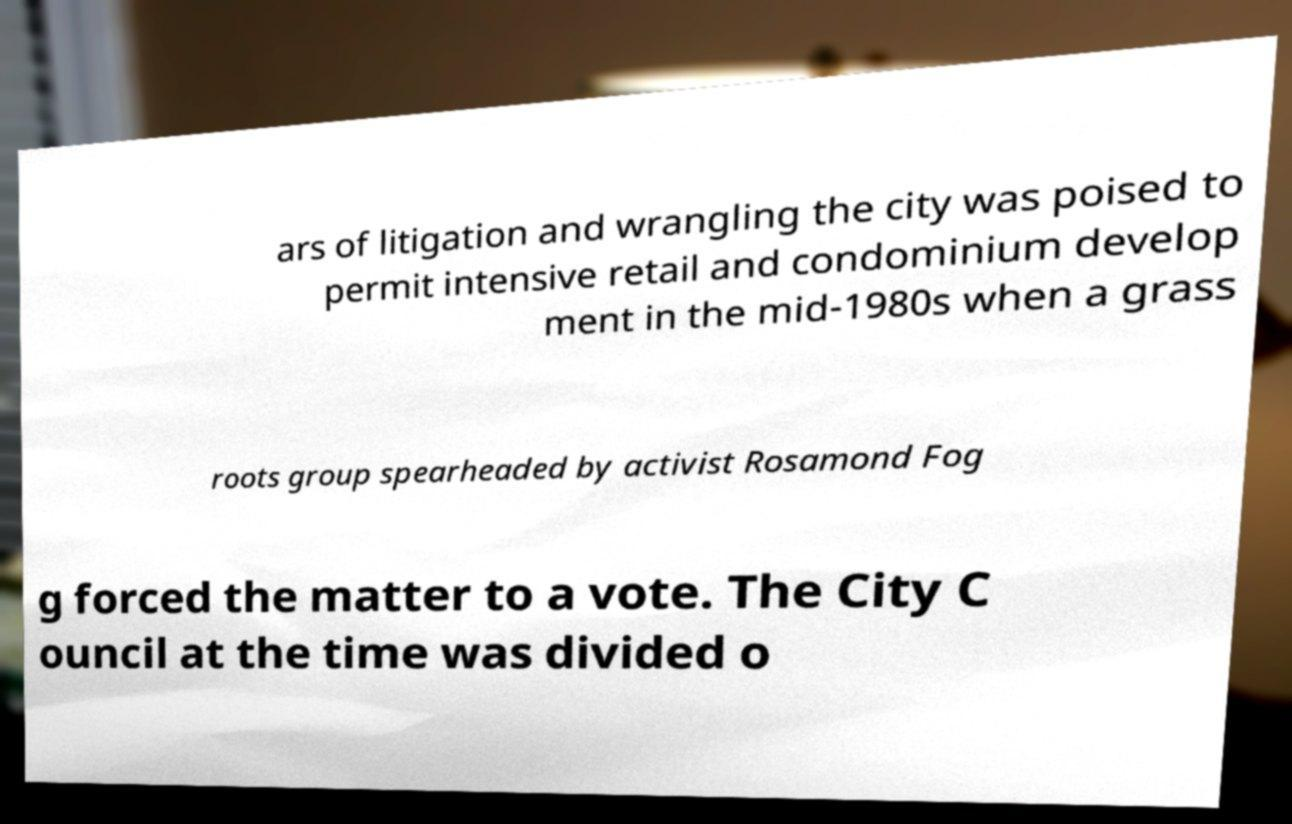Could you extract and type out the text from this image? ars of litigation and wrangling the city was poised to permit intensive retail and condominium develop ment in the mid-1980s when a grass roots group spearheaded by activist Rosamond Fog g forced the matter to a vote. The City C ouncil at the time was divided o 